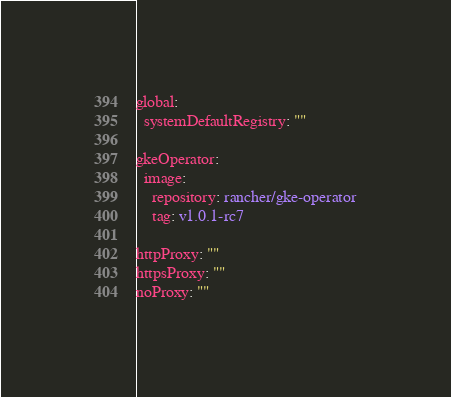<code> <loc_0><loc_0><loc_500><loc_500><_YAML_>global:
  systemDefaultRegistry: ""

gkeOperator:
  image:
    repository: rancher/gke-operator
    tag: v1.0.1-rc7

httpProxy: ""
httpsProxy: ""
noProxy: ""
</code> 